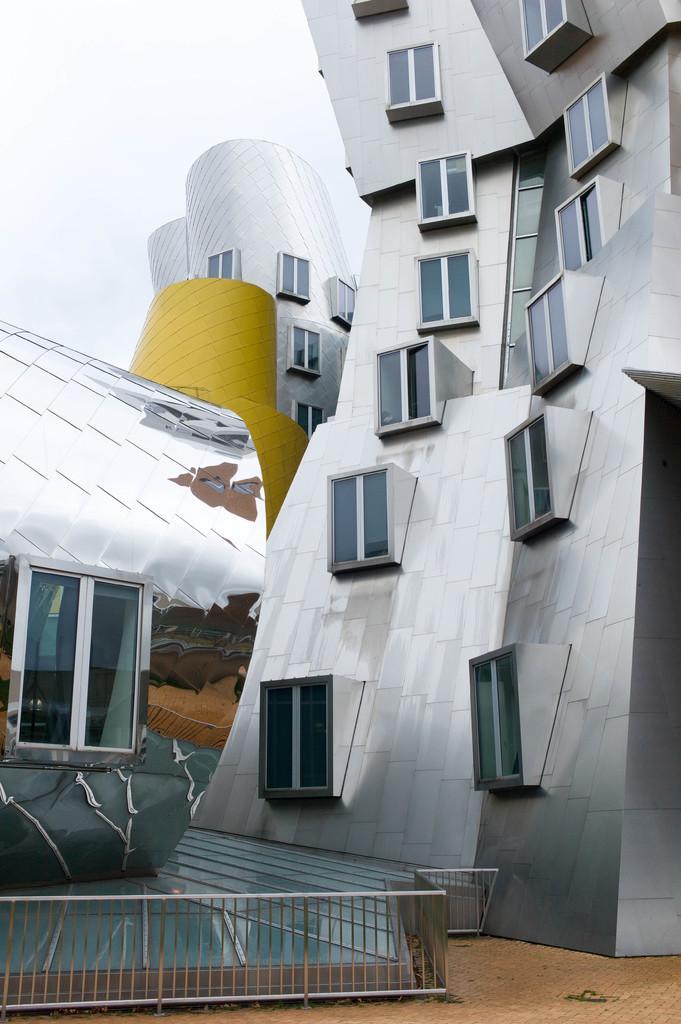Describe this image in one or two sentences. In this picture I can see buildings and a cloudy sky. 